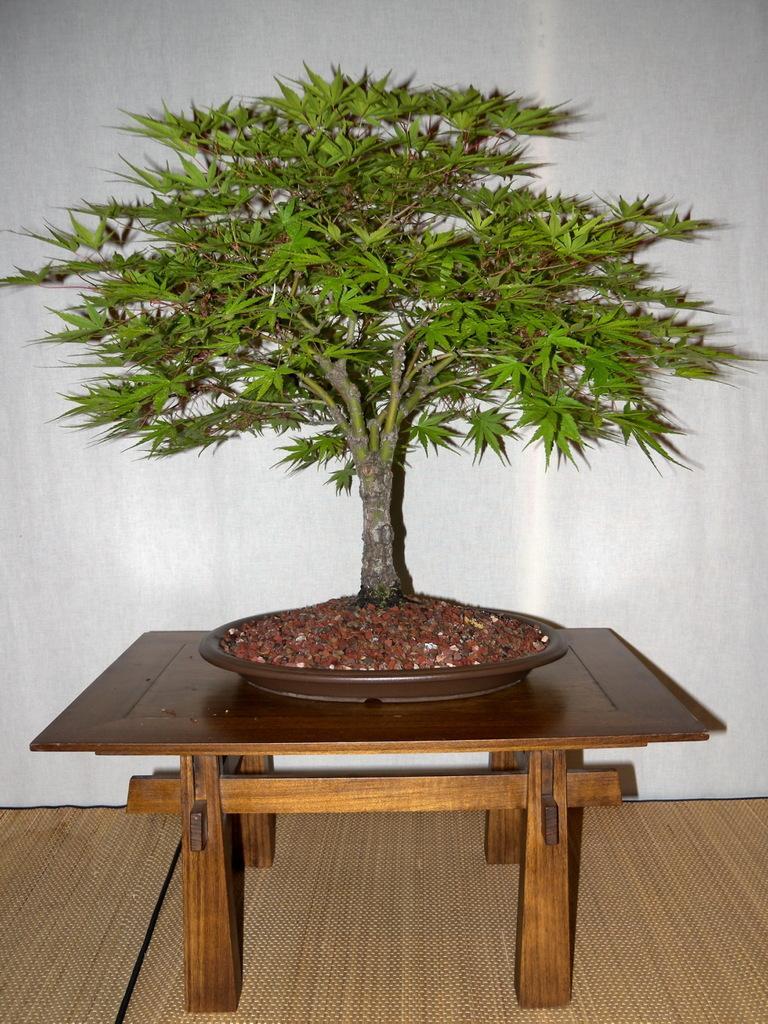Could you give a brief overview of what you see in this image? This picture is of plant placed on a table 